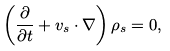<formula> <loc_0><loc_0><loc_500><loc_500>\left ( \frac { \partial } { \partial t } + { v } _ { s } \cdot \nabla \right ) \rho _ { s } = 0 ,</formula> 